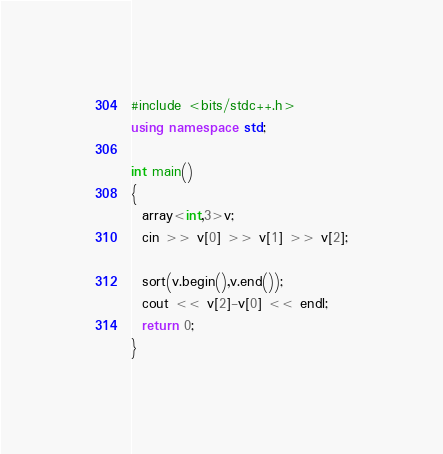Convert code to text. <code><loc_0><loc_0><loc_500><loc_500><_C++_>#include <bits/stdc++.h>
using namespace std;

int main()
{
  array<int,3>v;
  cin >> v[0] >> v[1] >> v[2];

  sort(v.begin(),v.end());
  cout << v[2]-v[0] << endl;
  return 0;
}</code> 